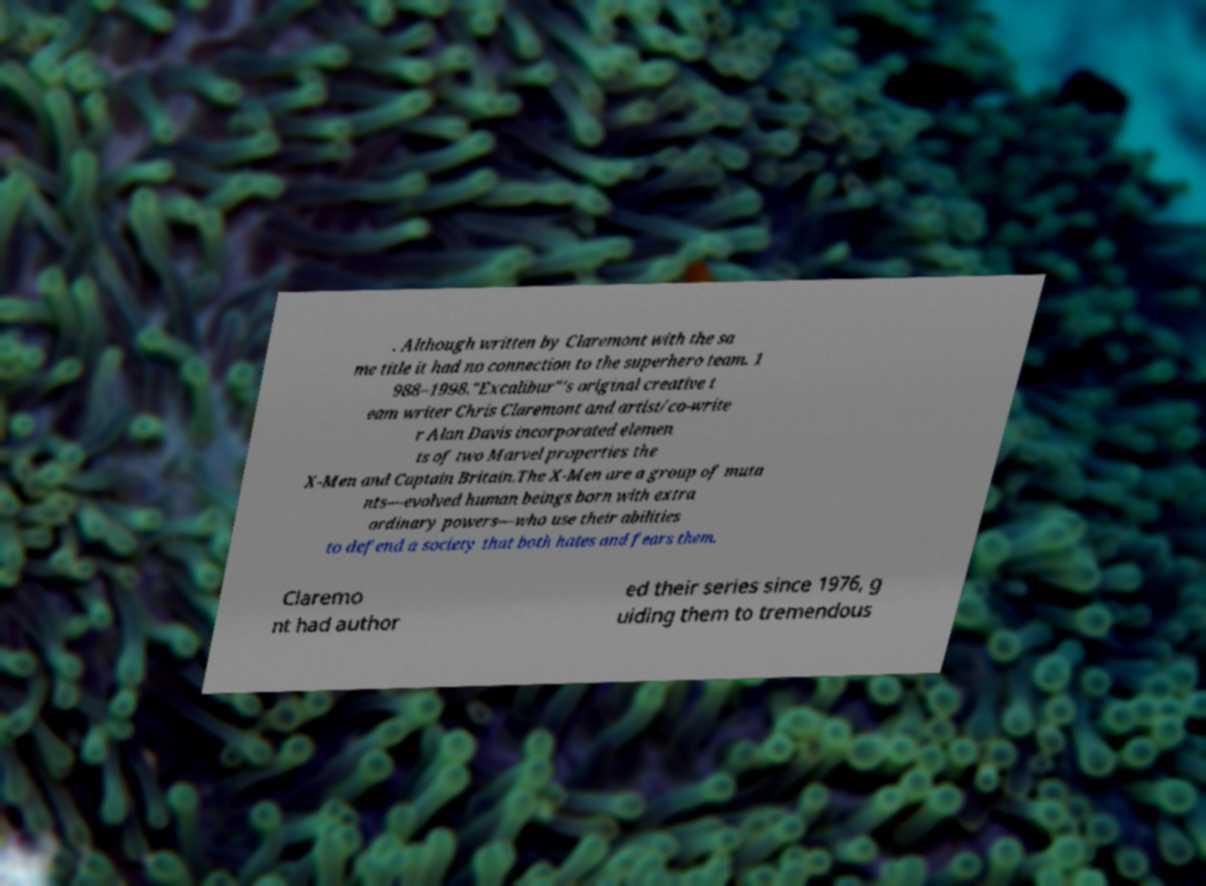Can you read and provide the text displayed in the image?This photo seems to have some interesting text. Can you extract and type it out for me? . Although written by Claremont with the sa me title it had no connection to the superhero team. 1 988–1998."Excalibur"'s original creative t eam writer Chris Claremont and artist/co-write r Alan Davis incorporated elemen ts of two Marvel properties the X-Men and Captain Britain.The X-Men are a group of muta nts—evolved human beings born with extra ordinary powers—who use their abilities to defend a society that both hates and fears them. Claremo nt had author ed their series since 1976, g uiding them to tremendous 